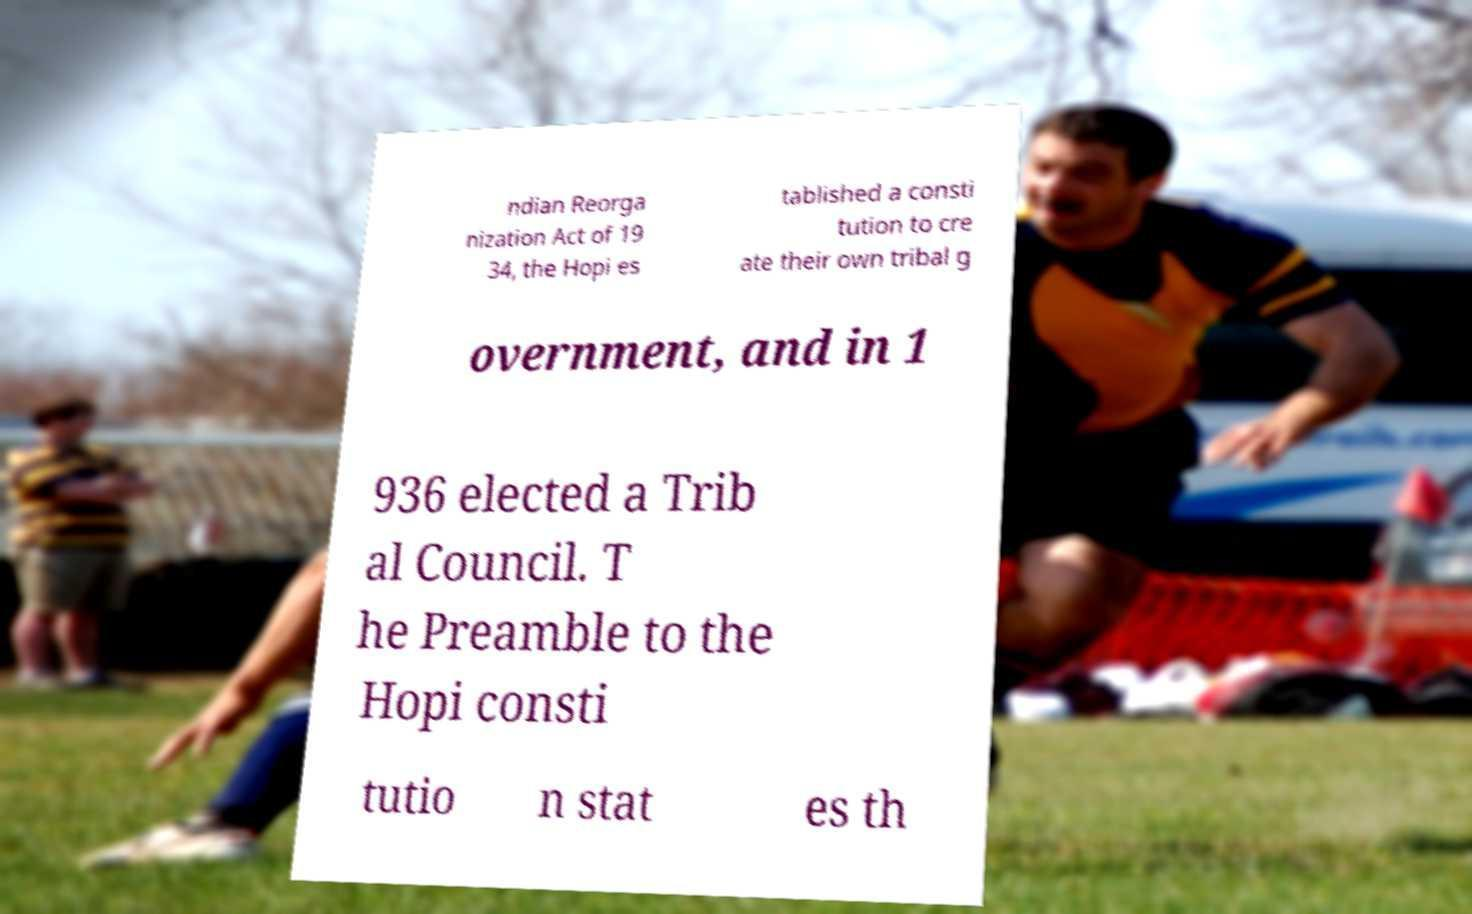For documentation purposes, I need the text within this image transcribed. Could you provide that? ndian Reorga nization Act of 19 34, the Hopi es tablished a consti tution to cre ate their own tribal g overnment, and in 1 936 elected a Trib al Council. T he Preamble to the Hopi consti tutio n stat es th 